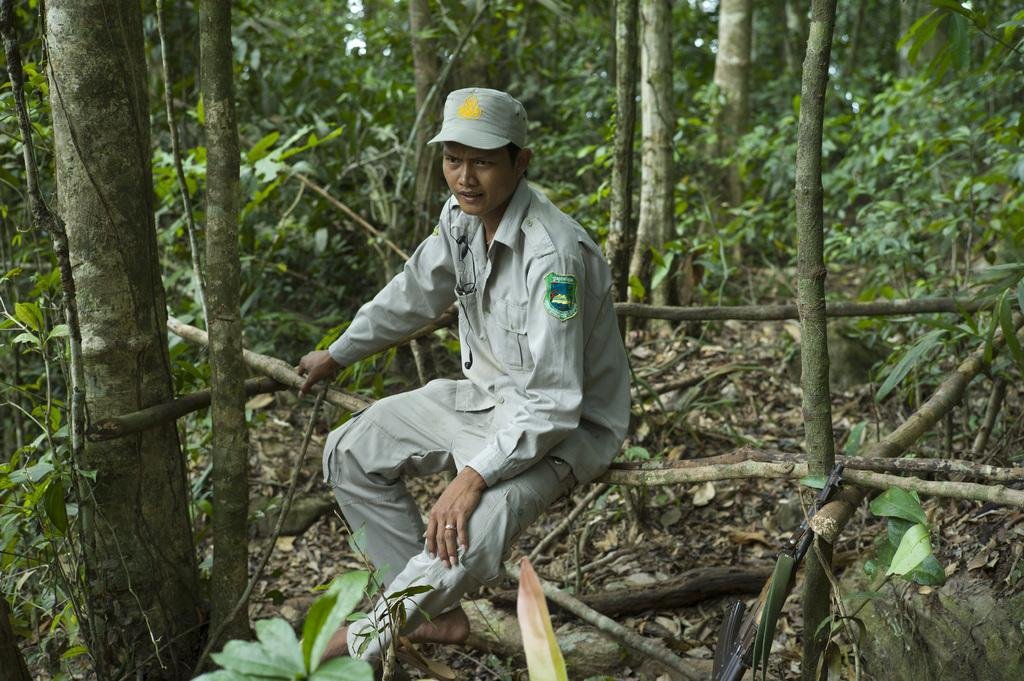What is the person in the image sitting on? The person is sitting on a wooden stick in the image. What can be seen surrounding the person? There are plants around the person. What type of vegetation is visible in the image? There are trees in the image. What is present on the surface at the bottom of the image? Dried leaves are present on the surface at the bottom of the image. How long does it take for the person to complete a trip around the sun in the image? The image does not depict a trip around the sun, so it is not possible to determine how long it would take for the person to complete such a journey. 